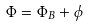<formula> <loc_0><loc_0><loc_500><loc_500>\Phi = \Phi _ { B } + \phi</formula> 